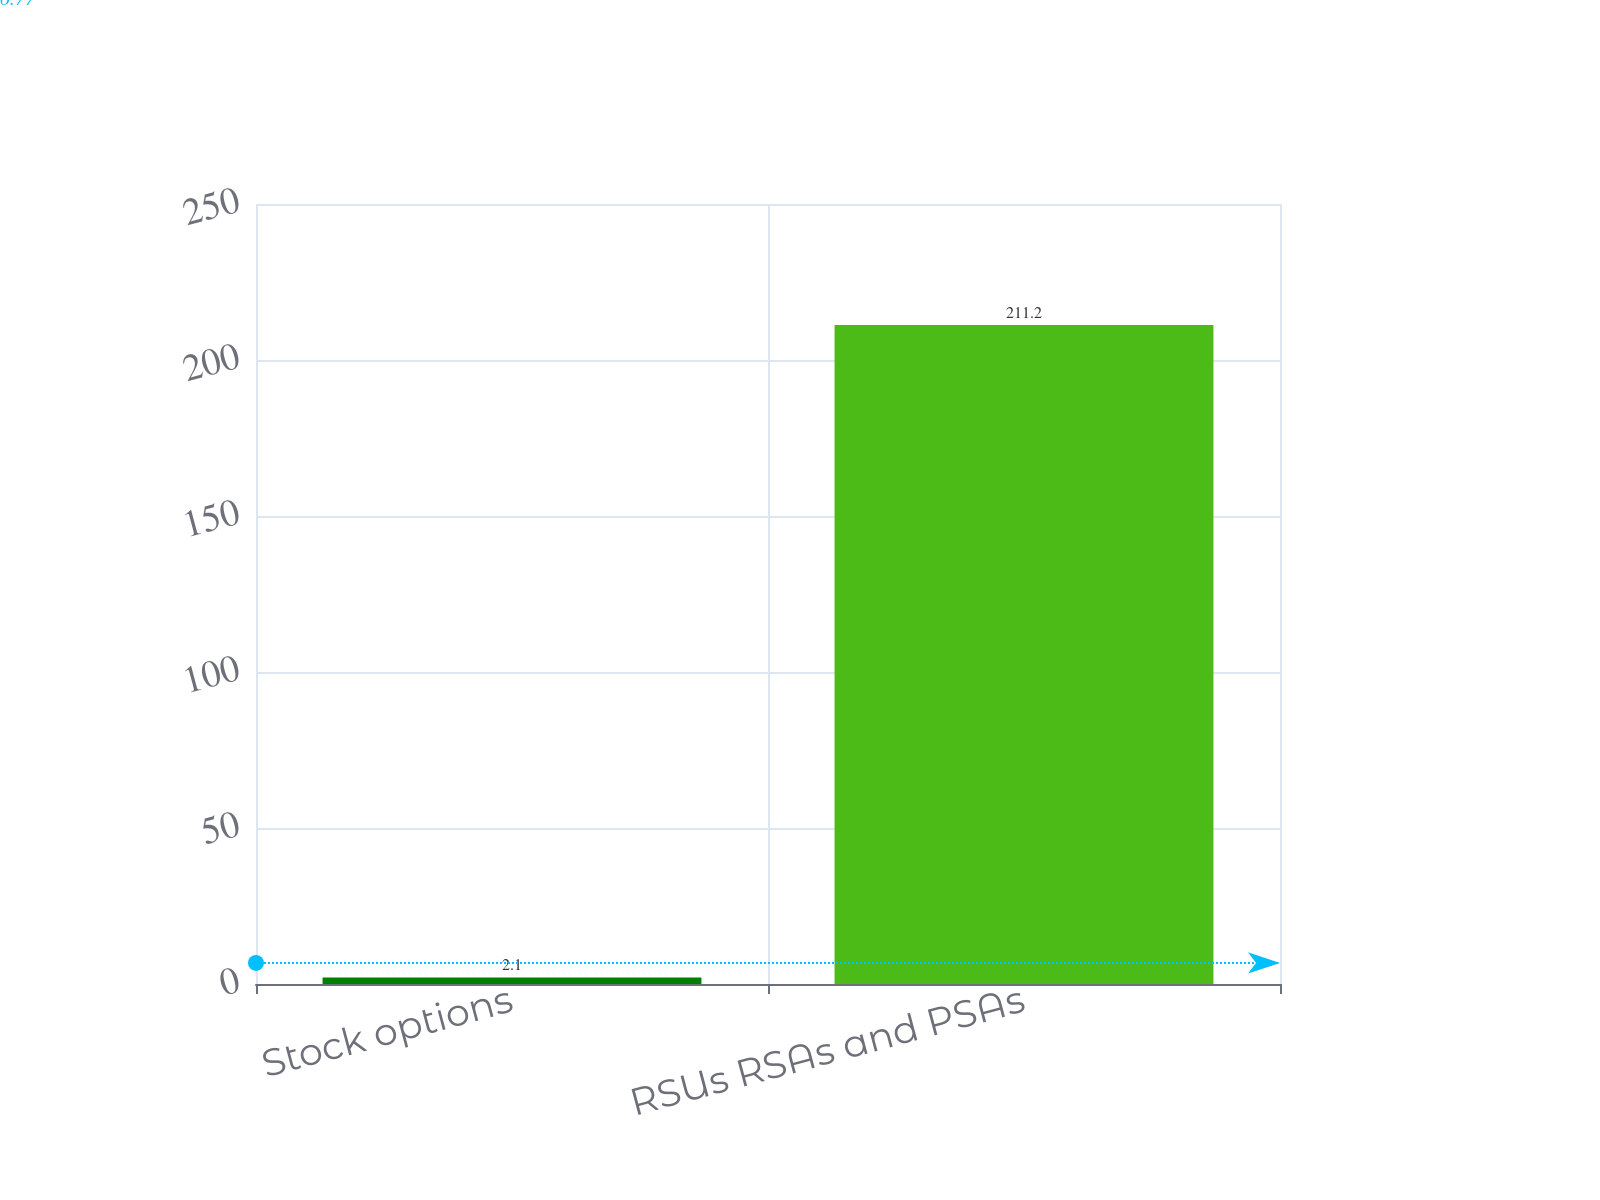Convert chart to OTSL. <chart><loc_0><loc_0><loc_500><loc_500><bar_chart><fcel>Stock options<fcel>RSUs RSAs and PSAs<nl><fcel>2.1<fcel>211.2<nl></chart> 